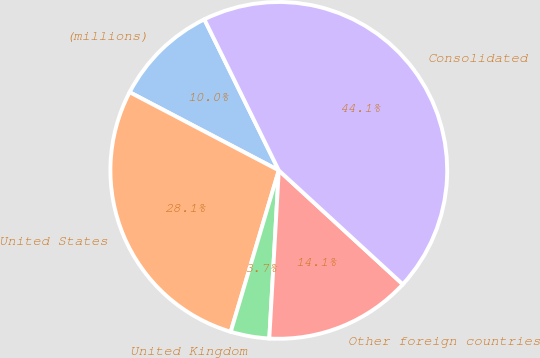Convert chart to OTSL. <chart><loc_0><loc_0><loc_500><loc_500><pie_chart><fcel>(millions)<fcel>United States<fcel>United Kingdom<fcel>Other foreign countries<fcel>Consolidated<nl><fcel>10.03%<fcel>28.08%<fcel>3.71%<fcel>14.07%<fcel>44.12%<nl></chart> 